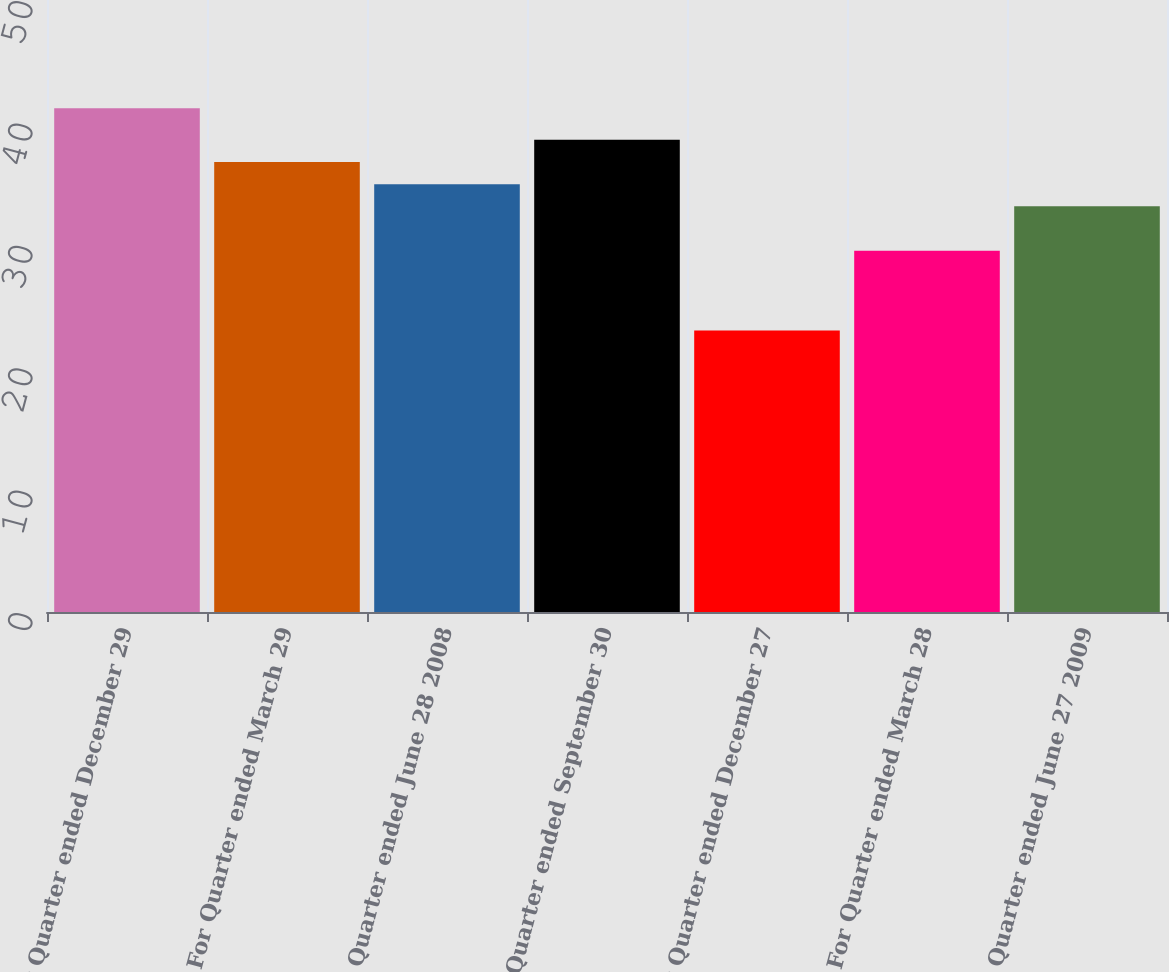<chart> <loc_0><loc_0><loc_500><loc_500><bar_chart><fcel>For Quarter ended December 29<fcel>For Quarter ended March 29<fcel>For Quarter ended June 28 2008<fcel>For Quarter ended September 30<fcel>For Quarter ended December 27<fcel>For Quarter ended March 28<fcel>For Quarter ended June 27 2009<nl><fcel>41.15<fcel>36.77<fcel>34.95<fcel>38.59<fcel>23<fcel>29.51<fcel>33.14<nl></chart> 